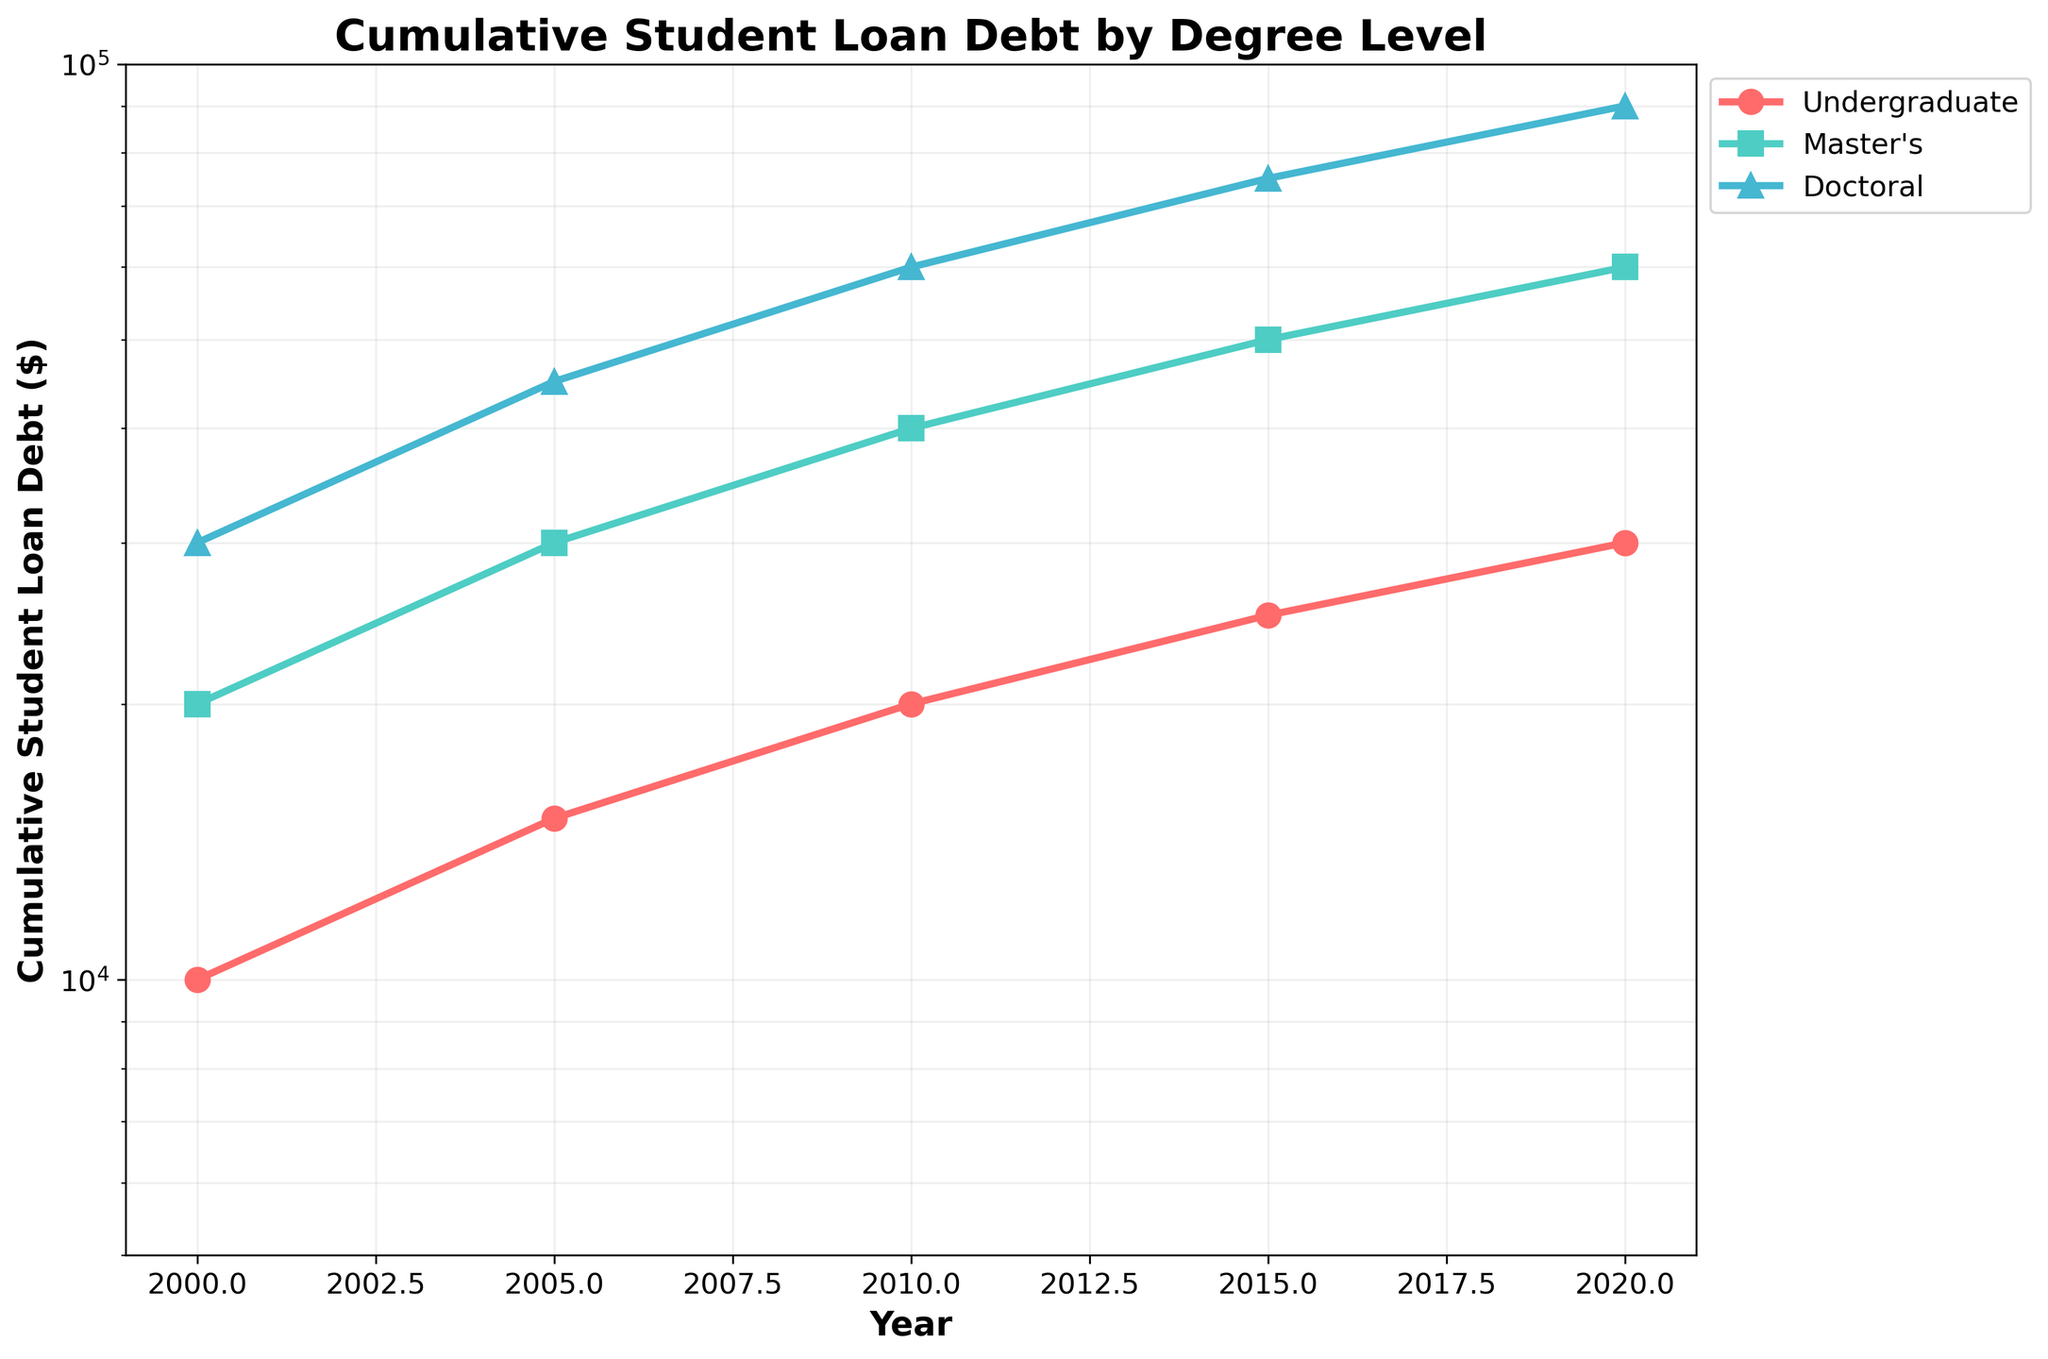What is the title of the plot? The title is usually placed at the top of the figure. In this case, it states: "Cumulative Student Loan Debt by Degree Level".
Answer: Cumulative Student Loan Debt by Degree Level Which degree level shows the highest cumulative student loan debt in 2020? To find this, look at the data points for the year 2020 across all degree levels and compare them. The Doctoral degree level has the highest point on the y-axis for 2020.
Answer: Doctoral What is the cumulative student loan debt for Master's degree in 2005? Locate the Master's degree line and find the data point corresponding to the year 2005. The y-axis value provides the cumulative debt.
Answer: 30,000 Between which two consecutive years did the Undergraduate cumulative student loan debt increase the most? Check the distance between each consecutive data point for the Undergraduate level on the log scale y-axis and identify the largest gap. The largest increase appears between 2000 and 2005.
Answer: 2000 and 2005 By how much did the Doctoral cumulative student loan debt increase from 2010 to 2015? Find the difference in the y-axis values for Doctoral debt between 2010 and 2015 to determine the increase. It increased from 60,000 to 75,000, so the difference is 15,000.
Answer: 15,000 On average, how much did the cumulative student loan debt increase every 5 years for the Master's degree between 2000 and 2020? Compute the total increase over 20 years and divide by the number of 5-year intervals. The debt increased from 20,000 to 60,000 in 20 years which is a total increase of 40,000. Divide this by 4 (20 years / 5 years per interval).
Answer: 10,000 Which degree level shows the least increase in cumulative student loan debt from 2000 to 2020? Compare the total increases over the period for all degree levels by looking at the difference between 2020 and 2000 values. Undergraduate increased from 10,000 to 30,000 (20,000 increase); Master's increased from 20,000 to 60,000 (40,000 increase); Doctoral from 30,000 to 90,000 (60,000 increase). The Undergraduate level had the least increase.
Answer: Undergraduate Which degree level had a cumulative student loan debt of 40,000 in 2010? Identify the data point at y=40,000 in the year 2010 across all degree levels. The Master's degree level matches this criterion.
Answer: Master's How does the cumulative student loan debt for Undergraduate degrees compare to Doctoral degrees in 2015? Find the y-axis values for both Undergraduate and Doctoral levels in 2015 and compare them. Undergraduate debt was 25,000, and Doctoral debt was 75,000. The Doctoral debt is three times the Undergraduate debt in 2015.
Answer: Doctoral debt is three times the Undergraduate debt What is the trend of cumulative student loan debt for all degree levels from 2000 to 2020? Observe the direction of the lines for each degree level over time. All lines show an increasing trend indicating rising cumulative student loan debt for each degree level from 2000 to 2020.
Answer: Increasing trend 